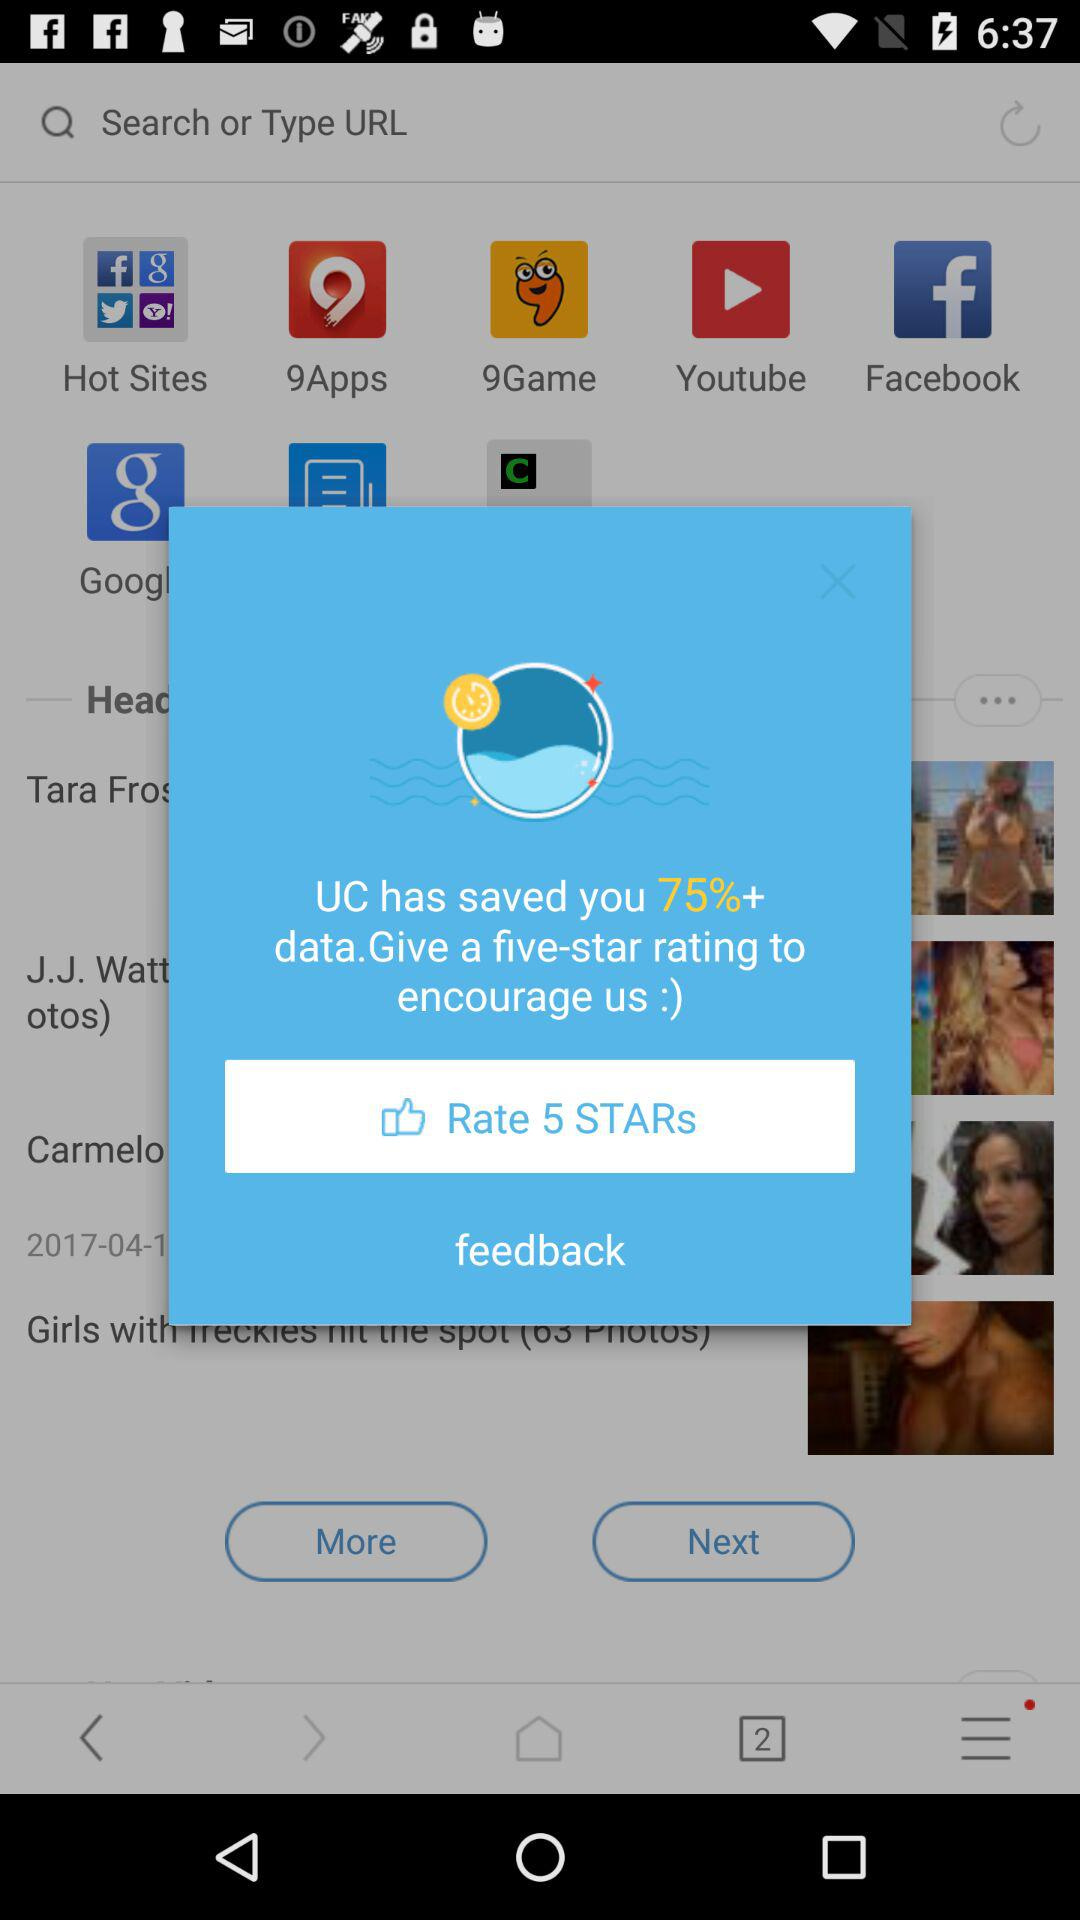What is the entered URL?
When the provided information is insufficient, respond with <no answer>. <no answer> 